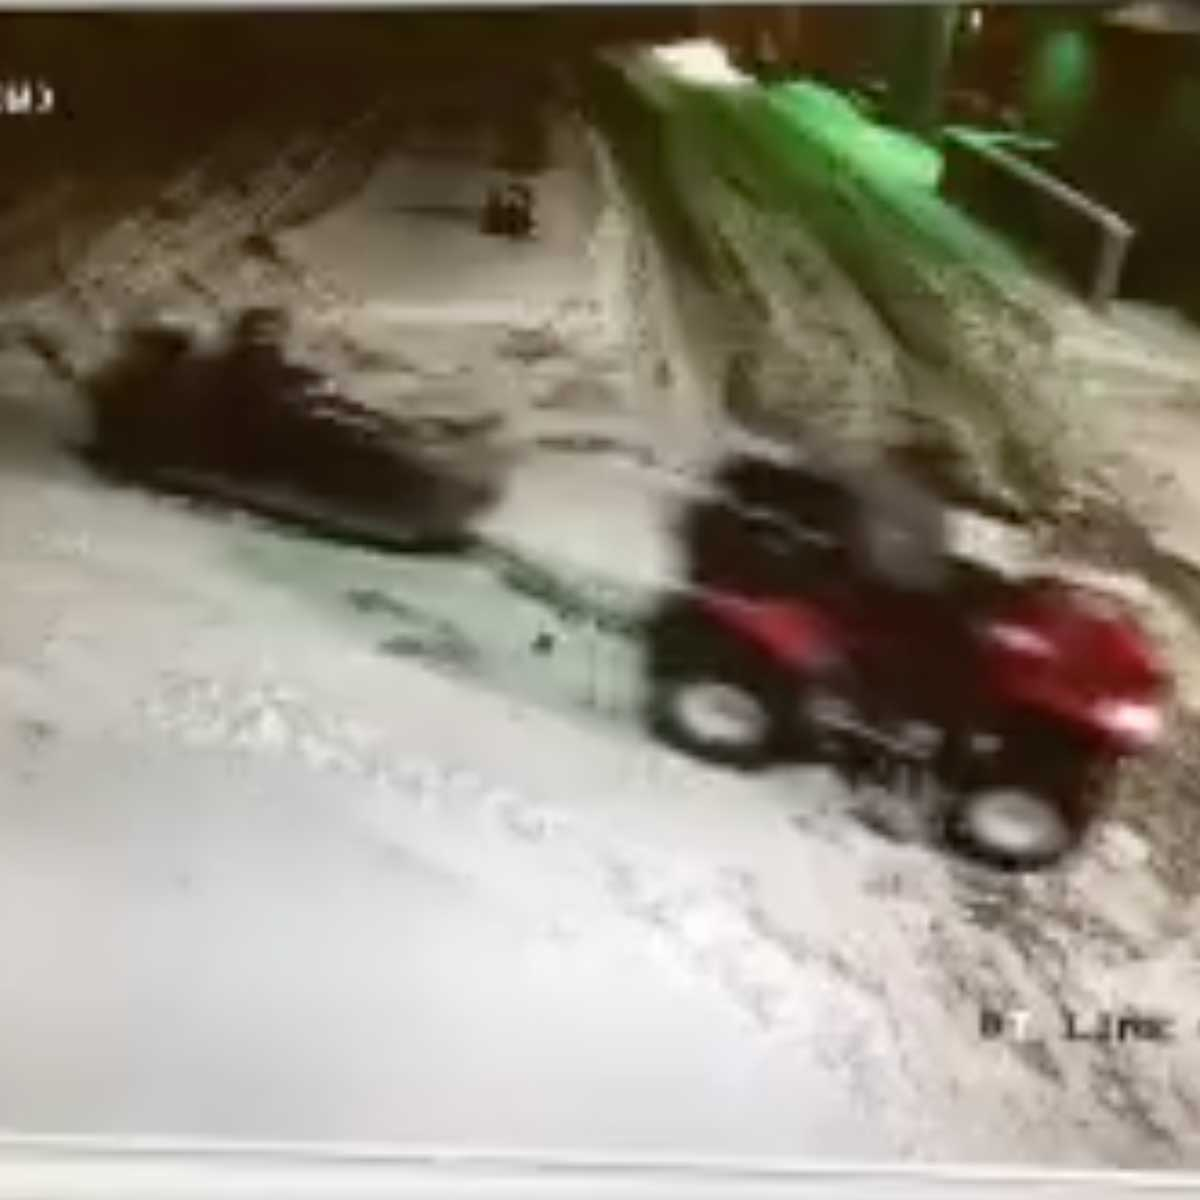What kind of weather conditions do you think this image represents? The image seems to suggest cold and snowy weather conditions, possibly during the evening or night. The snow appears to be quite thick, with tracks left behind by the vehicles indicating recent snowfall. The lighting suggests either artificial light or a low angle of natural sunlight, consistent with late or early hours. The overall atmosphere feels cold and potentially slippery, which could impact the handling of the ATV. Can you list potential hazards that the ATV drivers might encounter in this scenario? Several potential hazards could be present in this snowy scenario:
1. **Slippery surfaces:** The snow and possible ice make it difficult to control the ATV, increasing the risk of skidding or losing traction.
2. **Low visibility:** If it is evening or night, the lighting conditions might be poor, making it hard to see obstacles or other vehicles.
3. **Hidden obstacles:** Snow can cover hazards like rocks, branches, or deep ruts, posing a danger to the vehicles.
4. **Mechanical issues:** Cold temperatures can affect the performance of the vehicles, leading to possible malfunctions or difficulties starting.
5. **Fatigue:** The drivers might be tired after a long day, reducing their reaction times and increasing the risk of accidents. Imagine the ATV is not just an ordinary vehicle but a sentient robot. What kind of mission could it be on in this scene? In this imaginative scenario, the ATV is a sentient robot named Rover, equipped with advanced AI and designed for exploration in extreme environments. Rover is on a critical mission to recover vital scientific data from remote sensors placed throughout the snowy region. These sensors are monitoring climate changes and seismic activity, crucial for predicting natural disasters and understanding global warming.

As Rover navigates through the treacherous terrain, it uses its sophisticated sensors to scan for any signs of danger or obstacles. The smaller, darker object in the distance is another robotic unit called Scout, which has placed the sensors but now requires repairs. Rover's mission is to retrieve the data, repair Scout, and ensure both robots safely return to the main research base. Along the way, Rover encounters various challenges such as heavy snowfall, hidden crevasses, and fluctuations in communication signals. Nevertheless, with its advanced AI and unwavering determination, Rover is committed to completing its mission and contributing valuable data for the future of Earth's climate research. 